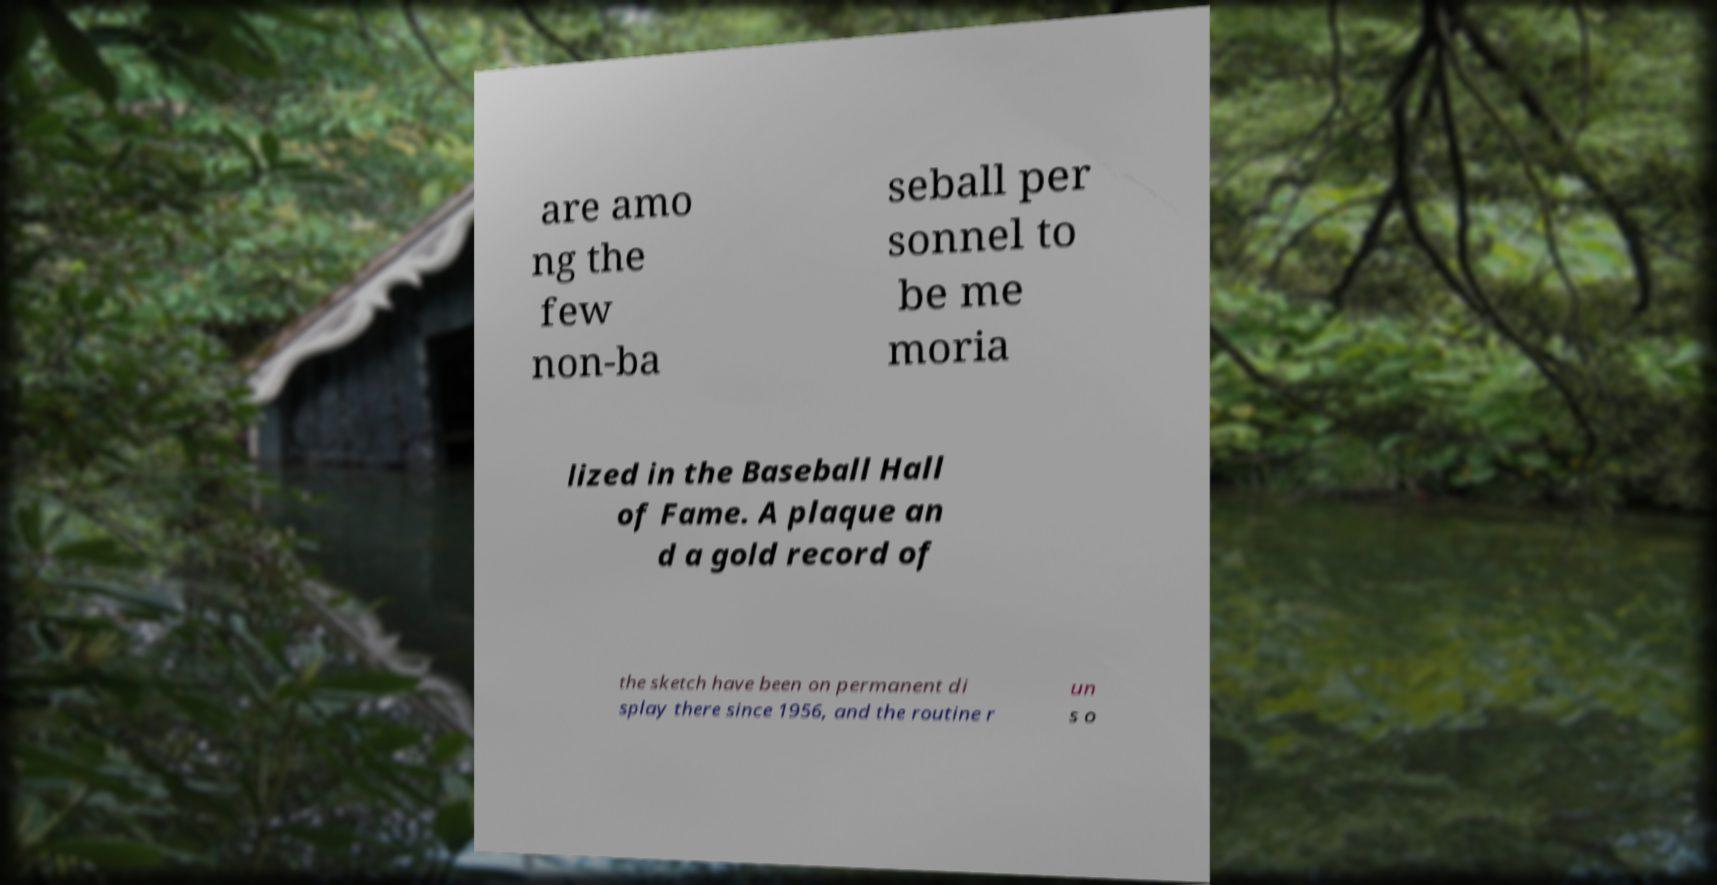There's text embedded in this image that I need extracted. Can you transcribe it verbatim? are amo ng the few non-ba seball per sonnel to be me moria lized in the Baseball Hall of Fame. A plaque an d a gold record of the sketch have been on permanent di splay there since 1956, and the routine r un s o 